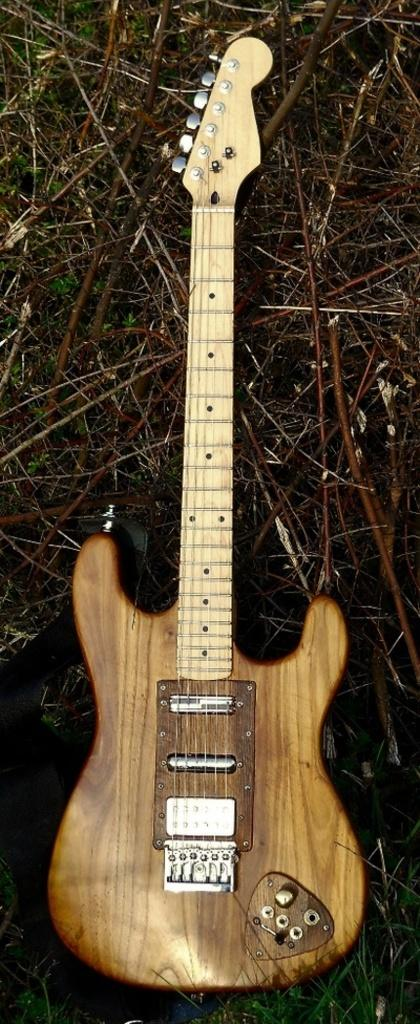What musical instrument is present in the image? There is a guitar in the image. How is the guitar positioned in the image? The guitar is placed on the ground. What color is the guitar in the image? The guitar is yellow in color. How many servants are attending to the guitar in the image? There are no servants present in the image; it only features a guitar placed on the ground. What type of needle is used to play the guitar in the image? There is no needle involved in playing the guitar in the image; it is played with the fingers or a pick. 